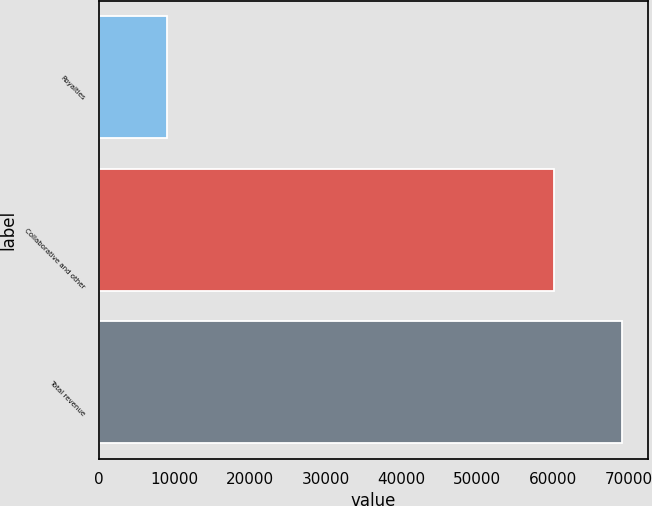Convert chart. <chart><loc_0><loc_0><loc_500><loc_500><bar_chart><fcel>Royalties<fcel>Collaborative and other<fcel>Total revenue<nl><fcel>9002<fcel>60139<fcel>69141<nl></chart> 